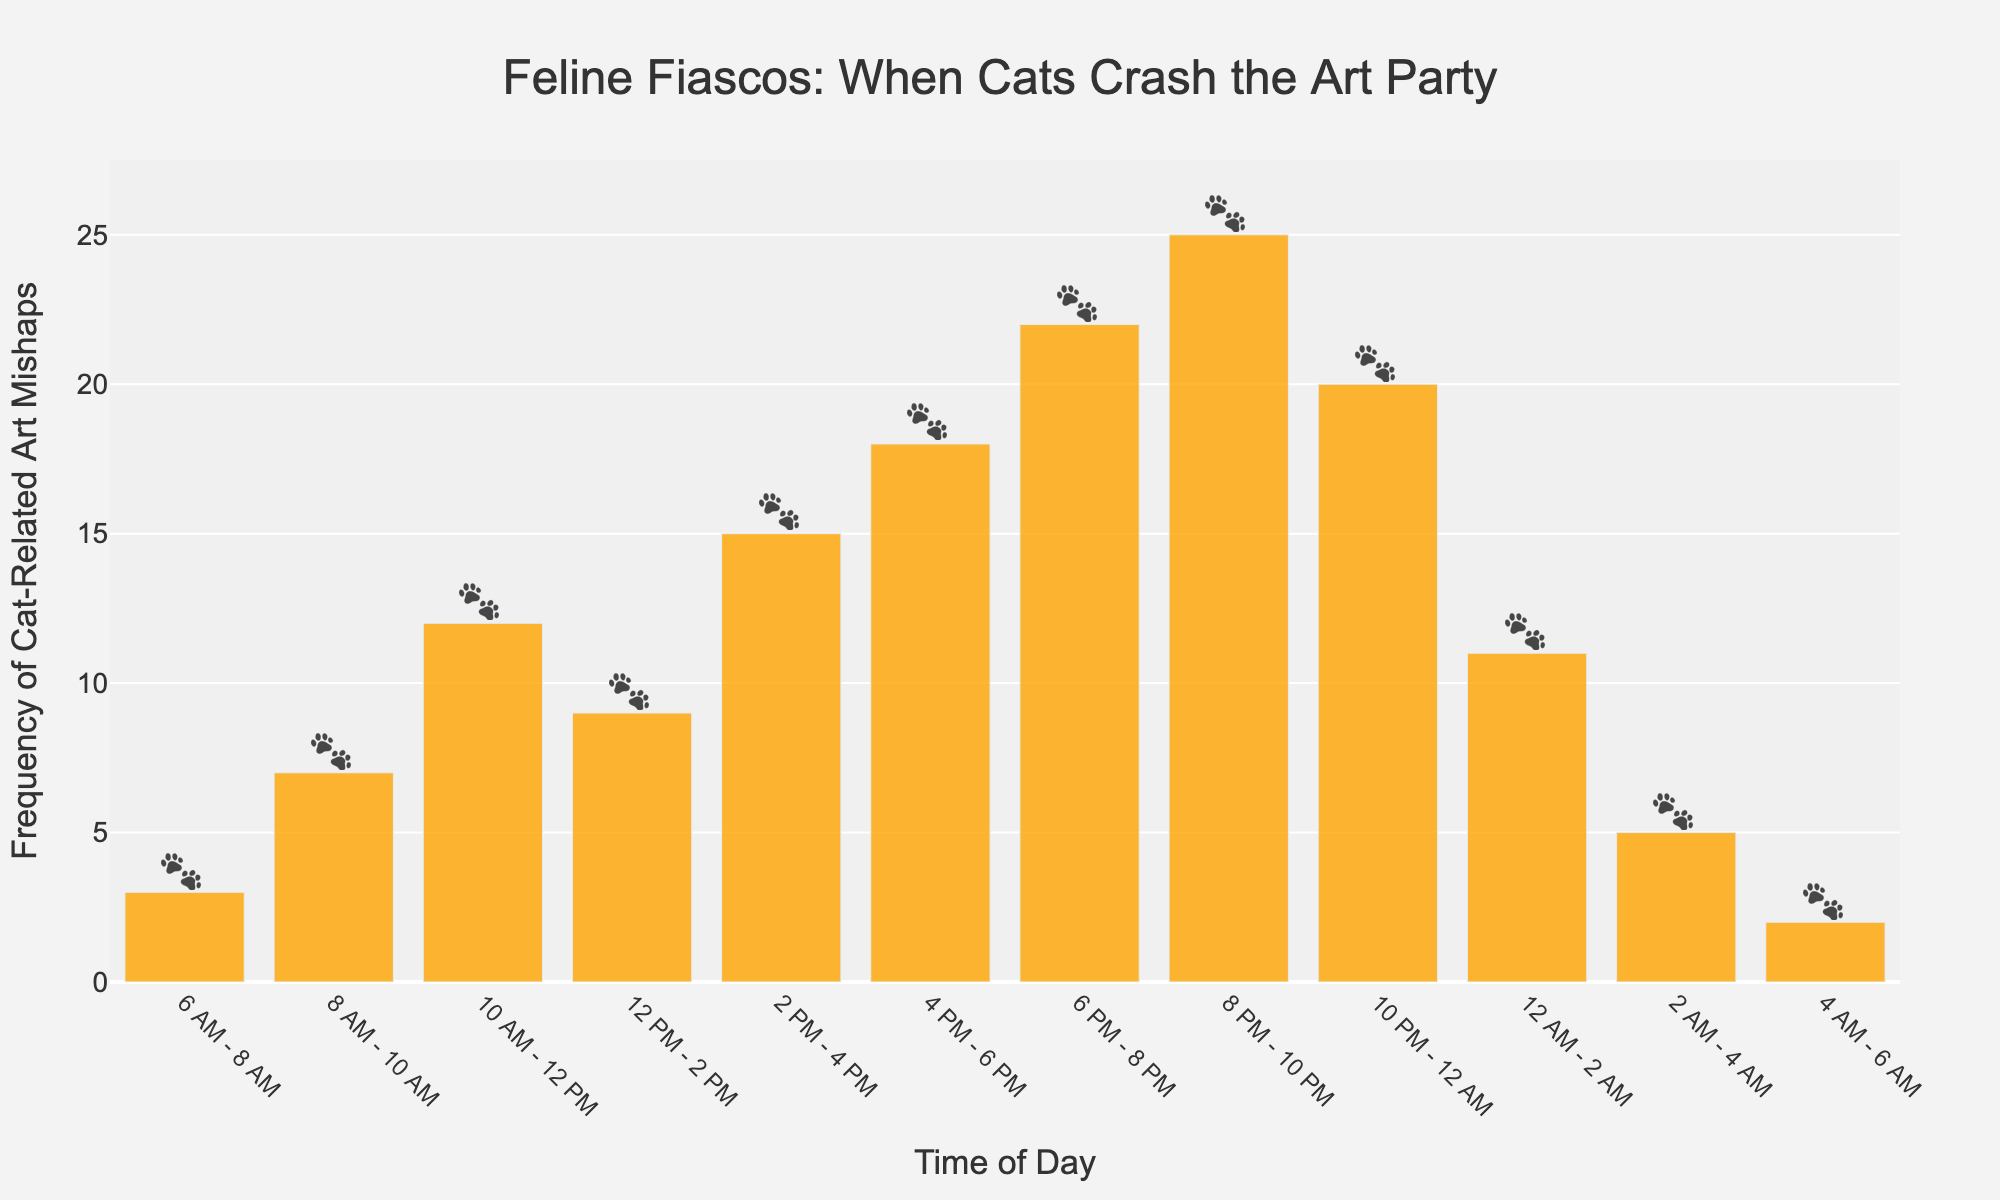What is the time of day with the highest frequency of cat-related art mishaps? According to the bar chart, the time slot with the highest frequency of cat-related art mishaps is from 8 PM to 10 PM, as it has the tallest bar.
Answer: 8 PM - 10 PM How much more frequent are cat-related art mishaps between 8 PM to 10 PM compared to 2 AM to 4 AM? From the chart, 8 PM to 10 PM has 25 mishaps, and 2 AM to 4 AM has 5 mishaps. The difference is calculated as 25 - 5 = 20.
Answer: 20 What is the sum of cat-related art mishaps from 6 PM to 8 PM and 8 PM to 10 PM? The frequencies are 22 for 6 PM - 8 PM and 25 for 8 PM - 10 PM. Adding them gives 22 + 25 = 47.
Answer: 47 Which time interval shows the second lowest frequency of cat-related art mishaps? The chart shows that the 4 AM to 6 AM interval has the lowest (2 mishaps), and the 6 AM to 8 AM interval has the second lowest with 3 mishaps.
Answer: 6 AM - 8 AM Is the frequency of mishaps from 4 PM to 6 PM greater than from 10 PM to 12 AM? From the chart, 4 PM to 6 PM has 18 mishaps, while 10 PM to 12 AM has 20 mishaps. 18 is less than 20.
Answer: No What is the average number of art mishaps between 6 AM to 8 AM and 8 AM to 10 AM? The frequencies are 3 and 7 respectively. The average is calculated as (3 + 7) / 2 = 5.
Answer: 5 During which time frame in the afternoon (12 PM - 6 PM) do the highest cat-related art mishaps occur? In the afternoon, the bar chart shows that 4 PM to 6 PM has the highest number of mishaps with 18 incidents.
Answer: 4 PM - 6 PM Compare the total mishaps occurring from 6 AM to 12 PM to those from 8 PM to 12 AM. Adding the morning intervals: 3 + 7 + 12 = 22, and the evening intervals: 25 + 20 = 45. Therefore, 22 vs 45.
Answer: 45 Which time slot from midnight to early morning (12 AM - 6 AM) has the highest occurrences of cat-related art mishaps? The chart shows that the interval from 12 AM to 2 AM has the highest frequency with 11 mishaps during this period.
Answer: 12 AM - 2 AM 